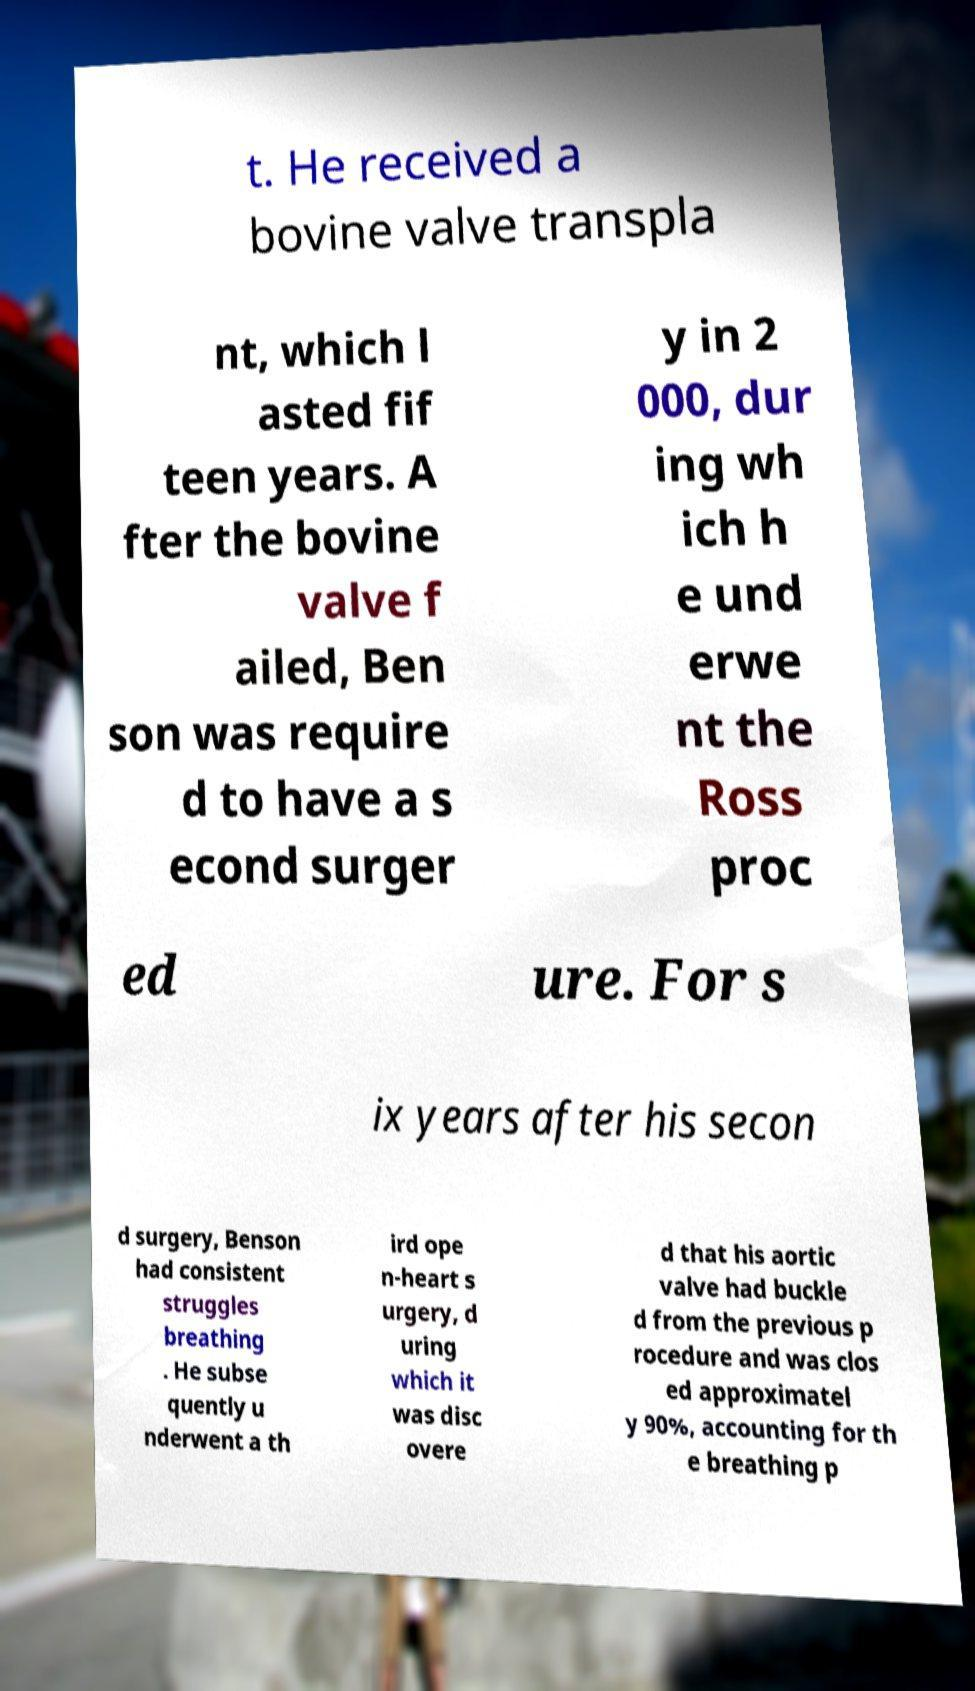I need the written content from this picture converted into text. Can you do that? t. He received a bovine valve transpla nt, which l asted fif teen years. A fter the bovine valve f ailed, Ben son was require d to have a s econd surger y in 2 000, dur ing wh ich h e und erwe nt the Ross proc ed ure. For s ix years after his secon d surgery, Benson had consistent struggles breathing . He subse quently u nderwent a th ird ope n-heart s urgery, d uring which it was disc overe d that his aortic valve had buckle d from the previous p rocedure and was clos ed approximatel y 90%, accounting for th e breathing p 